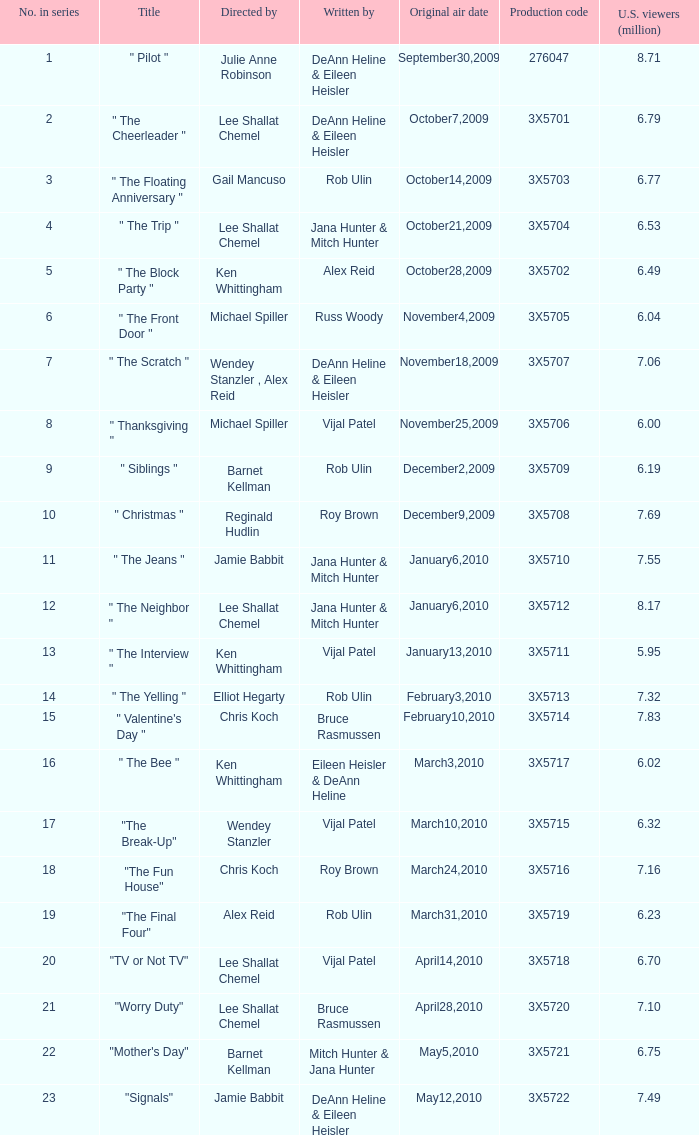What is the episode title that alex reid directed? "The Final Four". 